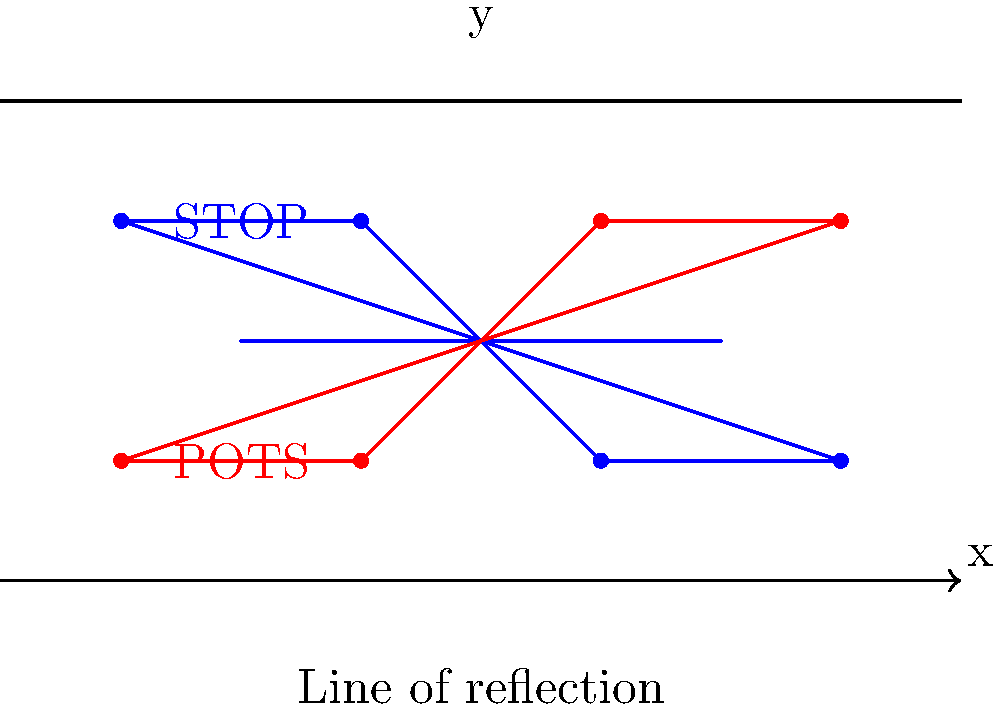A protest sign for gun control is reflected across the x-axis as shown in the diagram. If the original sign's vertices are at coordinates $(-1.5, 1.5)$, $(-0.5, 1.5)$, $(0.5, 0.5)$, and $(1.5, 0.5)$, what are the coordinates of the reflected sign's vertices? To find the coordinates of the reflected sign's vertices, we need to apply the principle of reflection across the x-axis. When reflecting a point $(x, y)$ across the x-axis, the x-coordinate remains the same, but the y-coordinate changes sign. So, $(x, y)$ becomes $(x, -y)$.

Let's reflect each vertex:

1. $(-1.5, 1.5)$ becomes $(-1.5, -1.5)$
2. $(-0.5, 1.5)$ becomes $(-0.5, -1.5)$
3. $(0.5, 0.5)$ becomes $(0.5, -0.5)$
4. $(1.5, 0.5)$ becomes $(1.5, -0.5)$

However, the question asks for the coordinates of the reflected sign, which is actually shown in the lower half of the coordinate plane. To get these coordinates, we need to negate the y-values of our initial reflection:

1. $(-1.5, -1.5)$ becomes $(-1.5, 0.5)$
2. $(-0.5, -1.5)$ becomes $(-0.5, 0.5)$
3. $(0.5, -0.5)$ becomes $(0.5, 1.5)$
4. $(1.5, -0.5)$ becomes $(1.5, 1.5)$

These are the coordinates of the vertices of the reflected sign.
Answer: $(-1.5, 0.5)$, $(-0.5, 0.5)$, $(0.5, 1.5)$, $(1.5, 1.5)$ 